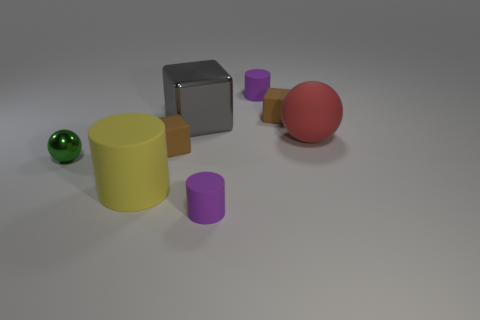Subtract all large blocks. How many blocks are left? 2 Add 1 gray metallic things. How many objects exist? 9 Subtract all purple cylinders. How many cylinders are left? 1 Subtract all gray cylinders. How many brown blocks are left? 2 Subtract all red cylinders. Subtract all gray balls. How many cylinders are left? 3 Subtract all small purple things. Subtract all small green metallic balls. How many objects are left? 5 Add 3 matte cylinders. How many matte cylinders are left? 6 Add 2 brown matte things. How many brown matte things exist? 4 Subtract 0 yellow cubes. How many objects are left? 8 Subtract all cylinders. How many objects are left? 5 